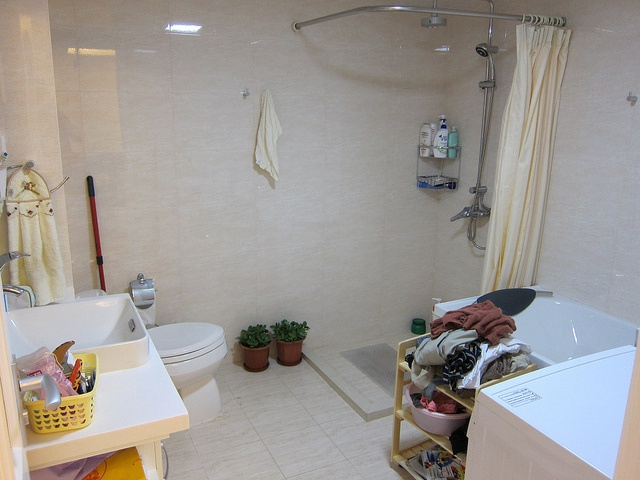Describe the objects in this image and their specific colors. I can see sink in gray, lightgray, darkgray, and tan tones, toilet in gray, darkgray, and lightgray tones, potted plant in gray, black, and maroon tones, potted plant in gray, black, and maroon tones, and bowl in gray, black, and darkgray tones in this image. 